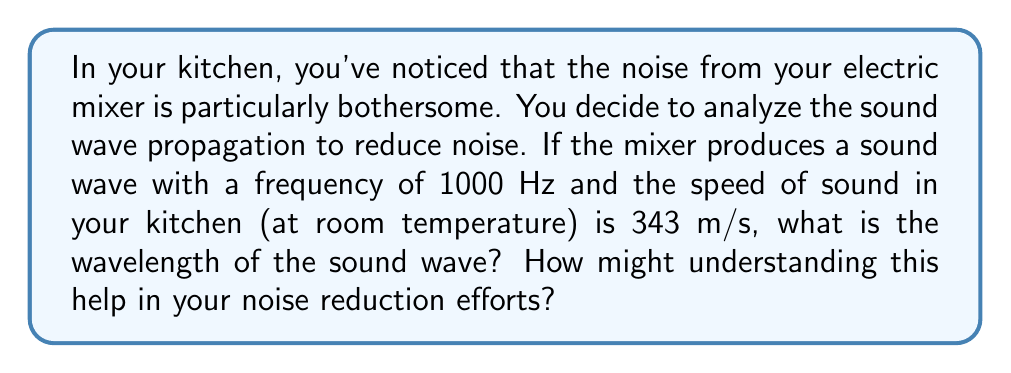Teach me how to tackle this problem. To solve this problem, we'll use the wave equation that relates wave speed, frequency, and wavelength:

$$v = f \lambda$$

Where:
$v$ = wave speed (m/s)
$f$ = frequency (Hz)
$\lambda$ = wavelength (m)

Given:
$v = 343$ m/s (speed of sound in air at room temperature)
$f = 1000$ Hz (frequency of the mixer's sound)

Step 1: Rearrange the wave equation to solve for wavelength:
$$\lambda = \frac{v}{f}$$

Step 2: Substitute the known values:
$$\lambda = \frac{343 \text{ m/s}}{1000 \text{ Hz}}$$

Step 3: Calculate the wavelength:
$$\lambda = 0.343 \text{ m}$$

Understanding the wavelength can help in noise reduction efforts:

1. Acoustic panels: Knowing the wavelength helps in choosing the right thickness for acoustic panels. Panels should be at least 1/4 of the wavelength thick to be effective.

2. Room layout: Avoid placing reflective surfaces at distances that are multiples of half the wavelength to prevent standing waves.

3. Mixer placement: Position the mixer away from walls or corners at distances that aren't multiples of the wavelength to minimize resonance.

4. Soundproofing materials: Choose materials that are effective at absorbing sounds with this wavelength.

By applying these principles, you can create a more acoustically pleasant kitchen environment while maintaining hygiene standards.
Answer: 0.343 m 